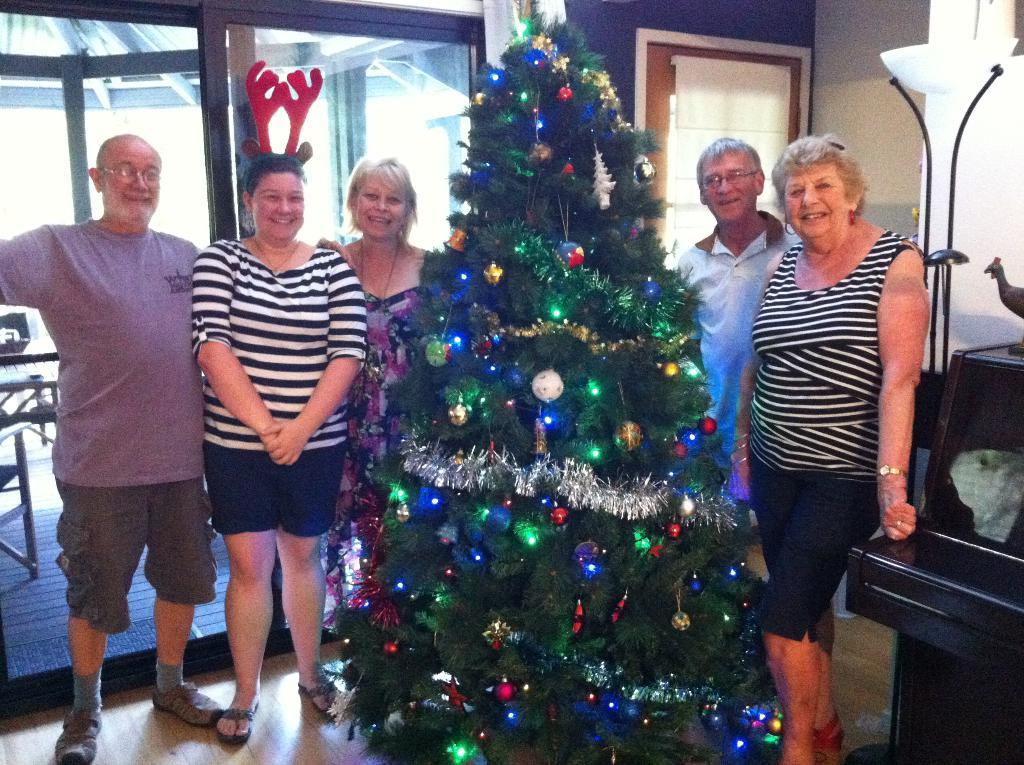How many people are in the group in the image? The number of people in the group cannot be determined from the provided facts. What is located in front of the group in the image? There is a Christmas tree in front of the group in the image. What can be seen in the background of the image? There are glass doors visible in the background of the image. What type of hat is the person in the center of the group wearing? There is no person in the center of the group, nor is there any mention of a hat in the provided facts. 